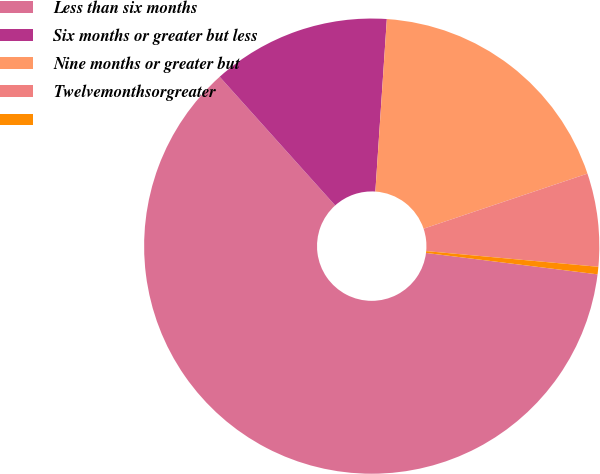Convert chart. <chart><loc_0><loc_0><loc_500><loc_500><pie_chart><fcel>Less than six months<fcel>Six months or greater but less<fcel>Nine months or greater but<fcel>Twelvemonthsorgreater<fcel>Unnamed: 4<nl><fcel>61.38%<fcel>12.7%<fcel>18.78%<fcel>6.61%<fcel>0.53%<nl></chart> 